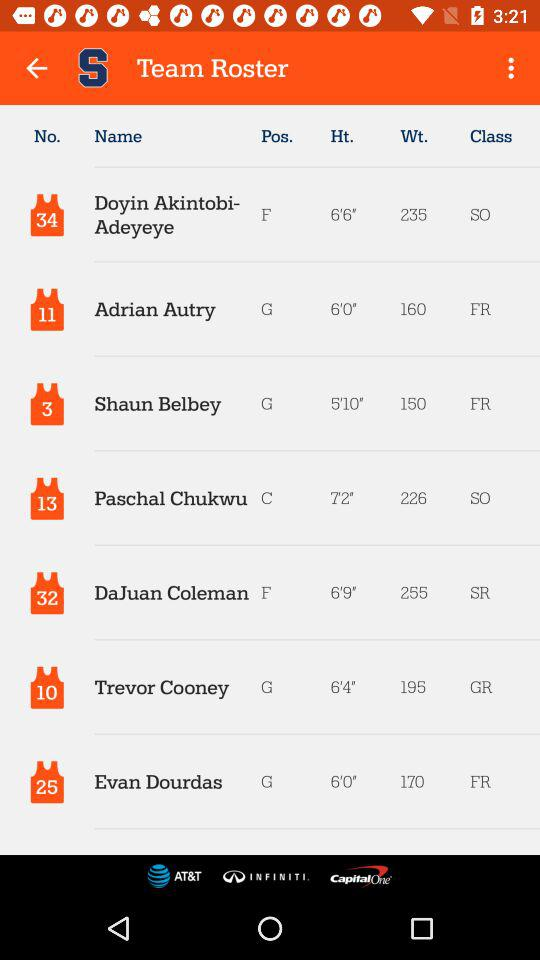What's the class of "Adrian Autry"? The class of "Adrian Autry" is "FR". 